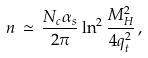Convert formula to latex. <formula><loc_0><loc_0><loc_500><loc_500>n \, \simeq \, \frac { N _ { c } \alpha _ { s } } { 2 \pi } \ln ^ { 2 } \frac { M ^ { 2 } _ { H } } { 4 q ^ { 2 } _ { t } } \, ,</formula> 